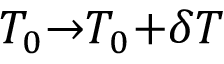Convert formula to latex. <formula><loc_0><loc_0><loc_500><loc_500>T _ { 0 } { \rightarrow } T _ { 0 } { + } \delta T</formula> 